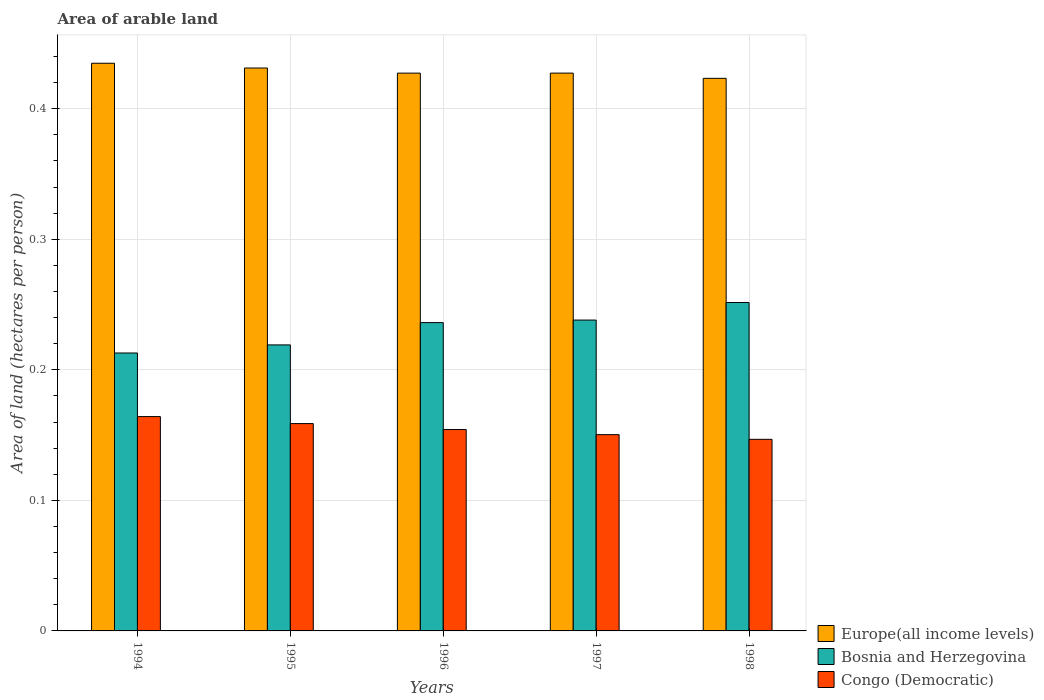How many groups of bars are there?
Provide a short and direct response. 5. Are the number of bars per tick equal to the number of legend labels?
Ensure brevity in your answer.  Yes. What is the total arable land in Europe(all income levels) in 1995?
Your response must be concise. 0.43. Across all years, what is the maximum total arable land in Congo (Democratic)?
Provide a succinct answer. 0.16. Across all years, what is the minimum total arable land in Europe(all income levels)?
Give a very brief answer. 0.42. In which year was the total arable land in Bosnia and Herzegovina minimum?
Offer a terse response. 1994. What is the total total arable land in Europe(all income levels) in the graph?
Ensure brevity in your answer.  2.14. What is the difference between the total arable land in Europe(all income levels) in 1996 and that in 1998?
Provide a succinct answer. 0. What is the difference between the total arable land in Europe(all income levels) in 1997 and the total arable land in Congo (Democratic) in 1996?
Your answer should be compact. 0.27. What is the average total arable land in Europe(all income levels) per year?
Your answer should be very brief. 0.43. In the year 1995, what is the difference between the total arable land in Bosnia and Herzegovina and total arable land in Congo (Democratic)?
Offer a very short reply. 0.06. In how many years, is the total arable land in Congo (Democratic) greater than 0.02 hectares per person?
Offer a very short reply. 5. What is the ratio of the total arable land in Congo (Democratic) in 1996 to that in 1997?
Provide a succinct answer. 1.03. Is the total arable land in Europe(all income levels) in 1996 less than that in 1997?
Your answer should be compact. Yes. What is the difference between the highest and the second highest total arable land in Congo (Democratic)?
Your response must be concise. 0.01. What is the difference between the highest and the lowest total arable land in Bosnia and Herzegovina?
Your response must be concise. 0.04. Is the sum of the total arable land in Bosnia and Herzegovina in 1995 and 1997 greater than the maximum total arable land in Europe(all income levels) across all years?
Provide a short and direct response. Yes. What does the 2nd bar from the left in 1996 represents?
Keep it short and to the point. Bosnia and Herzegovina. What does the 1st bar from the right in 1996 represents?
Your response must be concise. Congo (Democratic). Are the values on the major ticks of Y-axis written in scientific E-notation?
Provide a succinct answer. No. Where does the legend appear in the graph?
Offer a very short reply. Bottom right. What is the title of the graph?
Offer a terse response. Area of arable land. Does "Kazakhstan" appear as one of the legend labels in the graph?
Provide a short and direct response. No. What is the label or title of the Y-axis?
Keep it short and to the point. Area of land (hectares per person). What is the Area of land (hectares per person) in Europe(all income levels) in 1994?
Your answer should be very brief. 0.43. What is the Area of land (hectares per person) of Bosnia and Herzegovina in 1994?
Ensure brevity in your answer.  0.21. What is the Area of land (hectares per person) of Congo (Democratic) in 1994?
Ensure brevity in your answer.  0.16. What is the Area of land (hectares per person) of Europe(all income levels) in 1995?
Keep it short and to the point. 0.43. What is the Area of land (hectares per person) of Bosnia and Herzegovina in 1995?
Provide a succinct answer. 0.22. What is the Area of land (hectares per person) of Congo (Democratic) in 1995?
Keep it short and to the point. 0.16. What is the Area of land (hectares per person) of Europe(all income levels) in 1996?
Your answer should be compact. 0.43. What is the Area of land (hectares per person) of Bosnia and Herzegovina in 1996?
Provide a short and direct response. 0.24. What is the Area of land (hectares per person) in Congo (Democratic) in 1996?
Your response must be concise. 0.15. What is the Area of land (hectares per person) in Europe(all income levels) in 1997?
Ensure brevity in your answer.  0.43. What is the Area of land (hectares per person) in Bosnia and Herzegovina in 1997?
Offer a terse response. 0.24. What is the Area of land (hectares per person) in Congo (Democratic) in 1997?
Offer a very short reply. 0.15. What is the Area of land (hectares per person) of Europe(all income levels) in 1998?
Make the answer very short. 0.42. What is the Area of land (hectares per person) in Bosnia and Herzegovina in 1998?
Your answer should be very brief. 0.25. What is the Area of land (hectares per person) of Congo (Democratic) in 1998?
Provide a short and direct response. 0.15. Across all years, what is the maximum Area of land (hectares per person) of Europe(all income levels)?
Provide a succinct answer. 0.43. Across all years, what is the maximum Area of land (hectares per person) of Bosnia and Herzegovina?
Your response must be concise. 0.25. Across all years, what is the maximum Area of land (hectares per person) in Congo (Democratic)?
Your response must be concise. 0.16. Across all years, what is the minimum Area of land (hectares per person) in Europe(all income levels)?
Provide a short and direct response. 0.42. Across all years, what is the minimum Area of land (hectares per person) in Bosnia and Herzegovina?
Make the answer very short. 0.21. Across all years, what is the minimum Area of land (hectares per person) in Congo (Democratic)?
Your response must be concise. 0.15. What is the total Area of land (hectares per person) of Europe(all income levels) in the graph?
Your answer should be very brief. 2.14. What is the total Area of land (hectares per person) in Bosnia and Herzegovina in the graph?
Your answer should be compact. 1.16. What is the total Area of land (hectares per person) of Congo (Democratic) in the graph?
Make the answer very short. 0.77. What is the difference between the Area of land (hectares per person) in Europe(all income levels) in 1994 and that in 1995?
Provide a succinct answer. 0. What is the difference between the Area of land (hectares per person) of Bosnia and Herzegovina in 1994 and that in 1995?
Ensure brevity in your answer.  -0.01. What is the difference between the Area of land (hectares per person) in Congo (Democratic) in 1994 and that in 1995?
Your answer should be very brief. 0.01. What is the difference between the Area of land (hectares per person) in Europe(all income levels) in 1994 and that in 1996?
Keep it short and to the point. 0.01. What is the difference between the Area of land (hectares per person) in Bosnia and Herzegovina in 1994 and that in 1996?
Keep it short and to the point. -0.02. What is the difference between the Area of land (hectares per person) in Congo (Democratic) in 1994 and that in 1996?
Provide a short and direct response. 0.01. What is the difference between the Area of land (hectares per person) of Europe(all income levels) in 1994 and that in 1997?
Provide a succinct answer. 0.01. What is the difference between the Area of land (hectares per person) in Bosnia and Herzegovina in 1994 and that in 1997?
Make the answer very short. -0.03. What is the difference between the Area of land (hectares per person) in Congo (Democratic) in 1994 and that in 1997?
Your answer should be compact. 0.01. What is the difference between the Area of land (hectares per person) in Europe(all income levels) in 1994 and that in 1998?
Keep it short and to the point. 0.01. What is the difference between the Area of land (hectares per person) of Bosnia and Herzegovina in 1994 and that in 1998?
Give a very brief answer. -0.04. What is the difference between the Area of land (hectares per person) in Congo (Democratic) in 1994 and that in 1998?
Offer a very short reply. 0.02. What is the difference between the Area of land (hectares per person) in Europe(all income levels) in 1995 and that in 1996?
Keep it short and to the point. 0. What is the difference between the Area of land (hectares per person) in Bosnia and Herzegovina in 1995 and that in 1996?
Ensure brevity in your answer.  -0.02. What is the difference between the Area of land (hectares per person) in Congo (Democratic) in 1995 and that in 1996?
Your answer should be very brief. 0. What is the difference between the Area of land (hectares per person) in Europe(all income levels) in 1995 and that in 1997?
Keep it short and to the point. 0. What is the difference between the Area of land (hectares per person) of Bosnia and Herzegovina in 1995 and that in 1997?
Your answer should be very brief. -0.02. What is the difference between the Area of land (hectares per person) in Congo (Democratic) in 1995 and that in 1997?
Your response must be concise. 0.01. What is the difference between the Area of land (hectares per person) of Europe(all income levels) in 1995 and that in 1998?
Give a very brief answer. 0.01. What is the difference between the Area of land (hectares per person) of Bosnia and Herzegovina in 1995 and that in 1998?
Your answer should be very brief. -0.03. What is the difference between the Area of land (hectares per person) in Congo (Democratic) in 1995 and that in 1998?
Give a very brief answer. 0.01. What is the difference between the Area of land (hectares per person) of Europe(all income levels) in 1996 and that in 1997?
Keep it short and to the point. -0. What is the difference between the Area of land (hectares per person) of Bosnia and Herzegovina in 1996 and that in 1997?
Your response must be concise. -0. What is the difference between the Area of land (hectares per person) in Congo (Democratic) in 1996 and that in 1997?
Your answer should be very brief. 0. What is the difference between the Area of land (hectares per person) of Europe(all income levels) in 1996 and that in 1998?
Offer a terse response. 0. What is the difference between the Area of land (hectares per person) in Bosnia and Herzegovina in 1996 and that in 1998?
Keep it short and to the point. -0.02. What is the difference between the Area of land (hectares per person) of Congo (Democratic) in 1996 and that in 1998?
Ensure brevity in your answer.  0.01. What is the difference between the Area of land (hectares per person) in Europe(all income levels) in 1997 and that in 1998?
Your answer should be very brief. 0. What is the difference between the Area of land (hectares per person) in Bosnia and Herzegovina in 1997 and that in 1998?
Your answer should be compact. -0.01. What is the difference between the Area of land (hectares per person) in Congo (Democratic) in 1997 and that in 1998?
Provide a succinct answer. 0. What is the difference between the Area of land (hectares per person) of Europe(all income levels) in 1994 and the Area of land (hectares per person) of Bosnia and Herzegovina in 1995?
Make the answer very short. 0.22. What is the difference between the Area of land (hectares per person) of Europe(all income levels) in 1994 and the Area of land (hectares per person) of Congo (Democratic) in 1995?
Your response must be concise. 0.28. What is the difference between the Area of land (hectares per person) in Bosnia and Herzegovina in 1994 and the Area of land (hectares per person) in Congo (Democratic) in 1995?
Provide a succinct answer. 0.05. What is the difference between the Area of land (hectares per person) in Europe(all income levels) in 1994 and the Area of land (hectares per person) in Bosnia and Herzegovina in 1996?
Your answer should be compact. 0.2. What is the difference between the Area of land (hectares per person) in Europe(all income levels) in 1994 and the Area of land (hectares per person) in Congo (Democratic) in 1996?
Make the answer very short. 0.28. What is the difference between the Area of land (hectares per person) of Bosnia and Herzegovina in 1994 and the Area of land (hectares per person) of Congo (Democratic) in 1996?
Make the answer very short. 0.06. What is the difference between the Area of land (hectares per person) in Europe(all income levels) in 1994 and the Area of land (hectares per person) in Bosnia and Herzegovina in 1997?
Make the answer very short. 0.2. What is the difference between the Area of land (hectares per person) in Europe(all income levels) in 1994 and the Area of land (hectares per person) in Congo (Democratic) in 1997?
Ensure brevity in your answer.  0.28. What is the difference between the Area of land (hectares per person) in Bosnia and Herzegovina in 1994 and the Area of land (hectares per person) in Congo (Democratic) in 1997?
Your answer should be compact. 0.06. What is the difference between the Area of land (hectares per person) in Europe(all income levels) in 1994 and the Area of land (hectares per person) in Bosnia and Herzegovina in 1998?
Make the answer very short. 0.18. What is the difference between the Area of land (hectares per person) in Europe(all income levels) in 1994 and the Area of land (hectares per person) in Congo (Democratic) in 1998?
Offer a very short reply. 0.29. What is the difference between the Area of land (hectares per person) of Bosnia and Herzegovina in 1994 and the Area of land (hectares per person) of Congo (Democratic) in 1998?
Your response must be concise. 0.07. What is the difference between the Area of land (hectares per person) of Europe(all income levels) in 1995 and the Area of land (hectares per person) of Bosnia and Herzegovina in 1996?
Provide a succinct answer. 0.2. What is the difference between the Area of land (hectares per person) in Europe(all income levels) in 1995 and the Area of land (hectares per person) in Congo (Democratic) in 1996?
Offer a terse response. 0.28. What is the difference between the Area of land (hectares per person) in Bosnia and Herzegovina in 1995 and the Area of land (hectares per person) in Congo (Democratic) in 1996?
Offer a very short reply. 0.06. What is the difference between the Area of land (hectares per person) in Europe(all income levels) in 1995 and the Area of land (hectares per person) in Bosnia and Herzegovina in 1997?
Ensure brevity in your answer.  0.19. What is the difference between the Area of land (hectares per person) of Europe(all income levels) in 1995 and the Area of land (hectares per person) of Congo (Democratic) in 1997?
Provide a succinct answer. 0.28. What is the difference between the Area of land (hectares per person) in Bosnia and Herzegovina in 1995 and the Area of land (hectares per person) in Congo (Democratic) in 1997?
Your answer should be very brief. 0.07. What is the difference between the Area of land (hectares per person) of Europe(all income levels) in 1995 and the Area of land (hectares per person) of Bosnia and Herzegovina in 1998?
Your response must be concise. 0.18. What is the difference between the Area of land (hectares per person) of Europe(all income levels) in 1995 and the Area of land (hectares per person) of Congo (Democratic) in 1998?
Your answer should be very brief. 0.28. What is the difference between the Area of land (hectares per person) in Bosnia and Herzegovina in 1995 and the Area of land (hectares per person) in Congo (Democratic) in 1998?
Offer a terse response. 0.07. What is the difference between the Area of land (hectares per person) of Europe(all income levels) in 1996 and the Area of land (hectares per person) of Bosnia and Herzegovina in 1997?
Offer a terse response. 0.19. What is the difference between the Area of land (hectares per person) in Europe(all income levels) in 1996 and the Area of land (hectares per person) in Congo (Democratic) in 1997?
Make the answer very short. 0.28. What is the difference between the Area of land (hectares per person) in Bosnia and Herzegovina in 1996 and the Area of land (hectares per person) in Congo (Democratic) in 1997?
Provide a short and direct response. 0.09. What is the difference between the Area of land (hectares per person) in Europe(all income levels) in 1996 and the Area of land (hectares per person) in Bosnia and Herzegovina in 1998?
Offer a very short reply. 0.18. What is the difference between the Area of land (hectares per person) in Europe(all income levels) in 1996 and the Area of land (hectares per person) in Congo (Democratic) in 1998?
Your answer should be compact. 0.28. What is the difference between the Area of land (hectares per person) in Bosnia and Herzegovina in 1996 and the Area of land (hectares per person) in Congo (Democratic) in 1998?
Provide a succinct answer. 0.09. What is the difference between the Area of land (hectares per person) of Europe(all income levels) in 1997 and the Area of land (hectares per person) of Bosnia and Herzegovina in 1998?
Give a very brief answer. 0.18. What is the difference between the Area of land (hectares per person) of Europe(all income levels) in 1997 and the Area of land (hectares per person) of Congo (Democratic) in 1998?
Provide a succinct answer. 0.28. What is the difference between the Area of land (hectares per person) of Bosnia and Herzegovina in 1997 and the Area of land (hectares per person) of Congo (Democratic) in 1998?
Keep it short and to the point. 0.09. What is the average Area of land (hectares per person) of Europe(all income levels) per year?
Provide a succinct answer. 0.43. What is the average Area of land (hectares per person) of Bosnia and Herzegovina per year?
Offer a terse response. 0.23. What is the average Area of land (hectares per person) of Congo (Democratic) per year?
Your answer should be very brief. 0.15. In the year 1994, what is the difference between the Area of land (hectares per person) in Europe(all income levels) and Area of land (hectares per person) in Bosnia and Herzegovina?
Offer a terse response. 0.22. In the year 1994, what is the difference between the Area of land (hectares per person) in Europe(all income levels) and Area of land (hectares per person) in Congo (Democratic)?
Your answer should be compact. 0.27. In the year 1994, what is the difference between the Area of land (hectares per person) in Bosnia and Herzegovina and Area of land (hectares per person) in Congo (Democratic)?
Provide a short and direct response. 0.05. In the year 1995, what is the difference between the Area of land (hectares per person) in Europe(all income levels) and Area of land (hectares per person) in Bosnia and Herzegovina?
Provide a succinct answer. 0.21. In the year 1995, what is the difference between the Area of land (hectares per person) of Europe(all income levels) and Area of land (hectares per person) of Congo (Democratic)?
Keep it short and to the point. 0.27. In the year 1995, what is the difference between the Area of land (hectares per person) of Bosnia and Herzegovina and Area of land (hectares per person) of Congo (Democratic)?
Ensure brevity in your answer.  0.06. In the year 1996, what is the difference between the Area of land (hectares per person) in Europe(all income levels) and Area of land (hectares per person) in Bosnia and Herzegovina?
Make the answer very short. 0.19. In the year 1996, what is the difference between the Area of land (hectares per person) in Europe(all income levels) and Area of land (hectares per person) in Congo (Democratic)?
Keep it short and to the point. 0.27. In the year 1996, what is the difference between the Area of land (hectares per person) of Bosnia and Herzegovina and Area of land (hectares per person) of Congo (Democratic)?
Offer a terse response. 0.08. In the year 1997, what is the difference between the Area of land (hectares per person) of Europe(all income levels) and Area of land (hectares per person) of Bosnia and Herzegovina?
Your answer should be compact. 0.19. In the year 1997, what is the difference between the Area of land (hectares per person) of Europe(all income levels) and Area of land (hectares per person) of Congo (Democratic)?
Offer a terse response. 0.28. In the year 1997, what is the difference between the Area of land (hectares per person) of Bosnia and Herzegovina and Area of land (hectares per person) of Congo (Democratic)?
Your response must be concise. 0.09. In the year 1998, what is the difference between the Area of land (hectares per person) in Europe(all income levels) and Area of land (hectares per person) in Bosnia and Herzegovina?
Your answer should be very brief. 0.17. In the year 1998, what is the difference between the Area of land (hectares per person) in Europe(all income levels) and Area of land (hectares per person) in Congo (Democratic)?
Offer a terse response. 0.28. In the year 1998, what is the difference between the Area of land (hectares per person) of Bosnia and Herzegovina and Area of land (hectares per person) of Congo (Democratic)?
Provide a succinct answer. 0.1. What is the ratio of the Area of land (hectares per person) of Europe(all income levels) in 1994 to that in 1995?
Keep it short and to the point. 1.01. What is the ratio of the Area of land (hectares per person) in Bosnia and Herzegovina in 1994 to that in 1995?
Your answer should be compact. 0.97. What is the ratio of the Area of land (hectares per person) in Congo (Democratic) in 1994 to that in 1995?
Your answer should be very brief. 1.03. What is the ratio of the Area of land (hectares per person) in Europe(all income levels) in 1994 to that in 1996?
Your answer should be compact. 1.02. What is the ratio of the Area of land (hectares per person) in Bosnia and Herzegovina in 1994 to that in 1996?
Keep it short and to the point. 0.9. What is the ratio of the Area of land (hectares per person) of Congo (Democratic) in 1994 to that in 1996?
Make the answer very short. 1.06. What is the ratio of the Area of land (hectares per person) of Europe(all income levels) in 1994 to that in 1997?
Make the answer very short. 1.02. What is the ratio of the Area of land (hectares per person) in Bosnia and Herzegovina in 1994 to that in 1997?
Give a very brief answer. 0.89. What is the ratio of the Area of land (hectares per person) in Congo (Democratic) in 1994 to that in 1997?
Make the answer very short. 1.09. What is the ratio of the Area of land (hectares per person) of Europe(all income levels) in 1994 to that in 1998?
Offer a terse response. 1.03. What is the ratio of the Area of land (hectares per person) of Bosnia and Herzegovina in 1994 to that in 1998?
Your answer should be very brief. 0.85. What is the ratio of the Area of land (hectares per person) in Congo (Democratic) in 1994 to that in 1998?
Your answer should be compact. 1.12. What is the ratio of the Area of land (hectares per person) of Europe(all income levels) in 1995 to that in 1996?
Provide a succinct answer. 1.01. What is the ratio of the Area of land (hectares per person) of Bosnia and Herzegovina in 1995 to that in 1996?
Provide a succinct answer. 0.93. What is the ratio of the Area of land (hectares per person) of Congo (Democratic) in 1995 to that in 1996?
Your answer should be compact. 1.03. What is the ratio of the Area of land (hectares per person) in Europe(all income levels) in 1995 to that in 1997?
Keep it short and to the point. 1.01. What is the ratio of the Area of land (hectares per person) of Bosnia and Herzegovina in 1995 to that in 1997?
Give a very brief answer. 0.92. What is the ratio of the Area of land (hectares per person) in Congo (Democratic) in 1995 to that in 1997?
Your answer should be very brief. 1.06. What is the ratio of the Area of land (hectares per person) of Europe(all income levels) in 1995 to that in 1998?
Ensure brevity in your answer.  1.02. What is the ratio of the Area of land (hectares per person) in Bosnia and Herzegovina in 1995 to that in 1998?
Ensure brevity in your answer.  0.87. What is the ratio of the Area of land (hectares per person) in Congo (Democratic) in 1995 to that in 1998?
Offer a terse response. 1.08. What is the ratio of the Area of land (hectares per person) in Bosnia and Herzegovina in 1996 to that in 1997?
Offer a very short reply. 0.99. What is the ratio of the Area of land (hectares per person) in Congo (Democratic) in 1996 to that in 1997?
Your response must be concise. 1.03. What is the ratio of the Area of land (hectares per person) in Europe(all income levels) in 1996 to that in 1998?
Your response must be concise. 1.01. What is the ratio of the Area of land (hectares per person) of Bosnia and Herzegovina in 1996 to that in 1998?
Your response must be concise. 0.94. What is the ratio of the Area of land (hectares per person) of Congo (Democratic) in 1996 to that in 1998?
Ensure brevity in your answer.  1.05. What is the ratio of the Area of land (hectares per person) in Europe(all income levels) in 1997 to that in 1998?
Provide a short and direct response. 1.01. What is the ratio of the Area of land (hectares per person) in Bosnia and Herzegovina in 1997 to that in 1998?
Make the answer very short. 0.95. What is the ratio of the Area of land (hectares per person) of Congo (Democratic) in 1997 to that in 1998?
Keep it short and to the point. 1.02. What is the difference between the highest and the second highest Area of land (hectares per person) of Europe(all income levels)?
Your response must be concise. 0. What is the difference between the highest and the second highest Area of land (hectares per person) of Bosnia and Herzegovina?
Your answer should be very brief. 0.01. What is the difference between the highest and the second highest Area of land (hectares per person) in Congo (Democratic)?
Your response must be concise. 0.01. What is the difference between the highest and the lowest Area of land (hectares per person) of Europe(all income levels)?
Offer a terse response. 0.01. What is the difference between the highest and the lowest Area of land (hectares per person) of Bosnia and Herzegovina?
Provide a short and direct response. 0.04. What is the difference between the highest and the lowest Area of land (hectares per person) of Congo (Democratic)?
Ensure brevity in your answer.  0.02. 